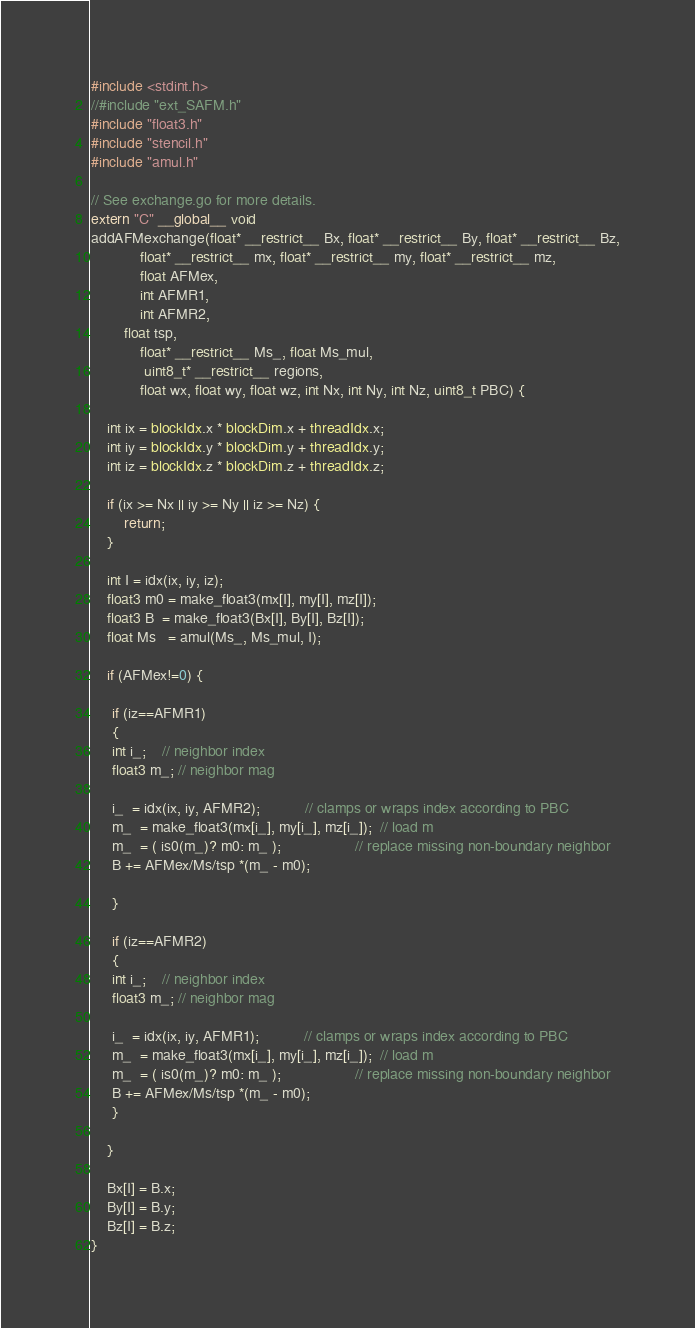Convert code to text. <code><loc_0><loc_0><loc_500><loc_500><_Cuda_>#include <stdint.h>
//#include "ext_SAFM.h"
#include "float3.h"
#include "stencil.h"
#include "amul.h"

// See exchange.go for more details.
extern "C" __global__ void
addAFMexchange(float* __restrict__ Bx, float* __restrict__ By, float* __restrict__ Bz,
            float* __restrict__ mx, float* __restrict__ my, float* __restrict__ mz,
            float AFMex, 
            int AFMR1, 
            int AFMR2,
	    float tsp,
            float* __restrict__ Ms_, float Ms_mul,
             uint8_t* __restrict__ regions,
            float wx, float wy, float wz, int Nx, int Ny, int Nz, uint8_t PBC) {

    int ix = blockIdx.x * blockDim.x + threadIdx.x;
    int iy = blockIdx.y * blockDim.y + threadIdx.y;
    int iz = blockIdx.z * blockDim.z + threadIdx.z;

    if (ix >= Nx || iy >= Ny || iz >= Nz) {
        return;
    }

    int I = idx(ix, iy, iz);
    float3 m0 = make_float3(mx[I], my[I], mz[I]);
    float3 B  = make_float3(Bx[I], By[I], Bz[I]);
    float Ms   = amul(Ms_, Ms_mul, I);

    if (AFMex!=0) {

     if (iz==AFMR1)
     {
     int i_;    // neighbor index
     float3 m_; // neighbor mag
 
     i_  = idx(ix, iy, AFMR2);           // clamps or wraps index according to PBC
     m_  = make_float3(mx[i_], my[i_], mz[i_]);  // load m
     m_  = ( is0(m_)? m0: m_ );                  // replace missing non-boundary neighbor
     B += AFMex/Ms/tsp *(m_ - m0);

     }

     if (iz==AFMR2)
     {
     int i_;    // neighbor index
     float3 m_; // neighbor mag
 
     i_  = idx(ix, iy, AFMR1);           // clamps or wraps index according to PBC
     m_  = make_float3(mx[i_], my[i_], mz[i_]);  // load m
     m_  = ( is0(m_)? m0: m_ );                  // replace missing non-boundary neighbor
     B += AFMex/Ms/tsp *(m_ - m0);
     }

    }

    Bx[I] = B.x;
    By[I] = B.y;
    Bz[I] = B.z;
}

</code> 